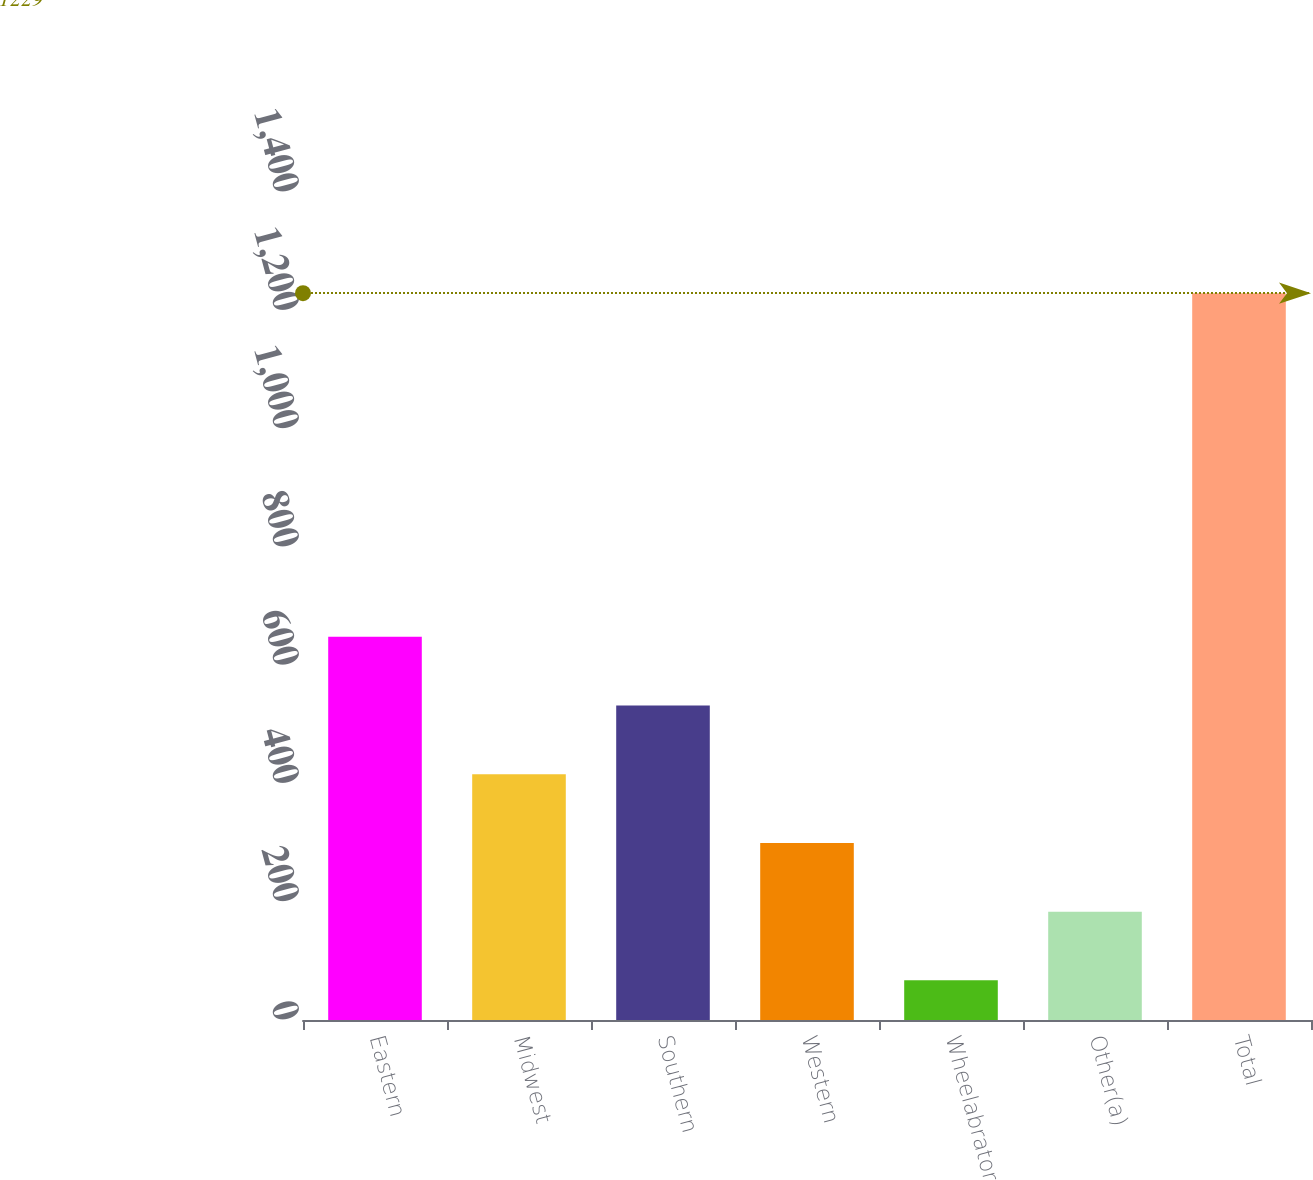Convert chart to OTSL. <chart><loc_0><loc_0><loc_500><loc_500><bar_chart><fcel>Eastern<fcel>Midwest<fcel>Southern<fcel>Western<fcel>Wheelabrator<fcel>Other(a)<fcel>Total<nl><fcel>648<fcel>415.6<fcel>531.8<fcel>299.4<fcel>67<fcel>183.2<fcel>1229<nl></chart> 